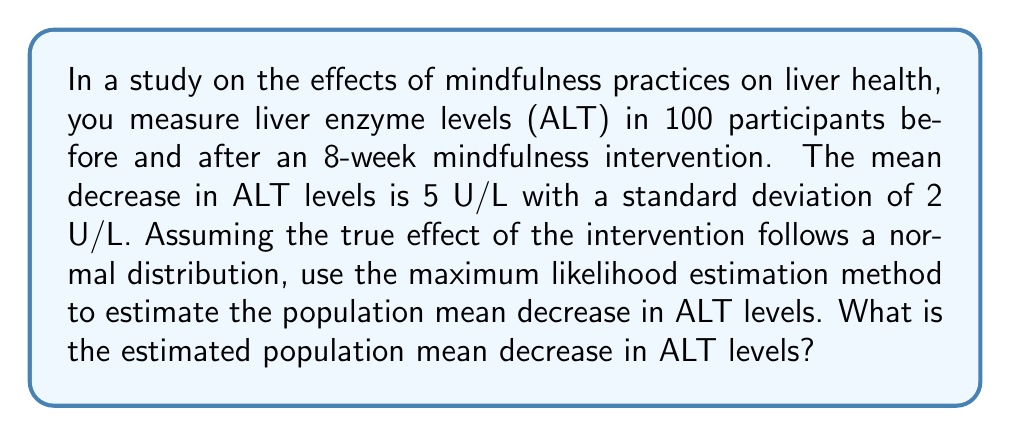Solve this math problem. To estimate the population mean decrease in ALT levels using the maximum likelihood estimation (MLE) method, we follow these steps:

1. Define the likelihood function:
   The likelihood function for a normal distribution is:
   $$L(\mu, \sigma^2 | x_1, ..., x_n) = \prod_{i=1}^n \frac{1}{\sqrt{2\pi\sigma^2}} e^{-\frac{(x_i - \mu)^2}{2\sigma^2}}$$

2. Take the natural logarithm of the likelihood function:
   $$\ln L(\mu, \sigma^2 | x_1, ..., x_n) = -\frac{n}{2}\ln(2\pi\sigma^2) - \frac{1}{2\sigma^2}\sum_{i=1}^n (x_i - \mu)^2$$

3. Differentiate the log-likelihood with respect to $\mu$ and set it to zero:
   $$\frac{\partial \ln L}{\partial \mu} = \frac{1}{\sigma^2}\sum_{i=1}^n (x_i - \mu) = 0$$

4. Solve for $\mu$:
   $$\sum_{i=1}^n x_i - n\mu = 0$$
   $$\mu = \frac{1}{n}\sum_{i=1}^n x_i$$

5. In this case, we are given the sample mean directly, which is the maximum likelihood estimator for the population mean. Therefore, the estimated population mean decrease in ALT levels is equal to the sample mean, which is 5 U/L.
Answer: 5 U/L 